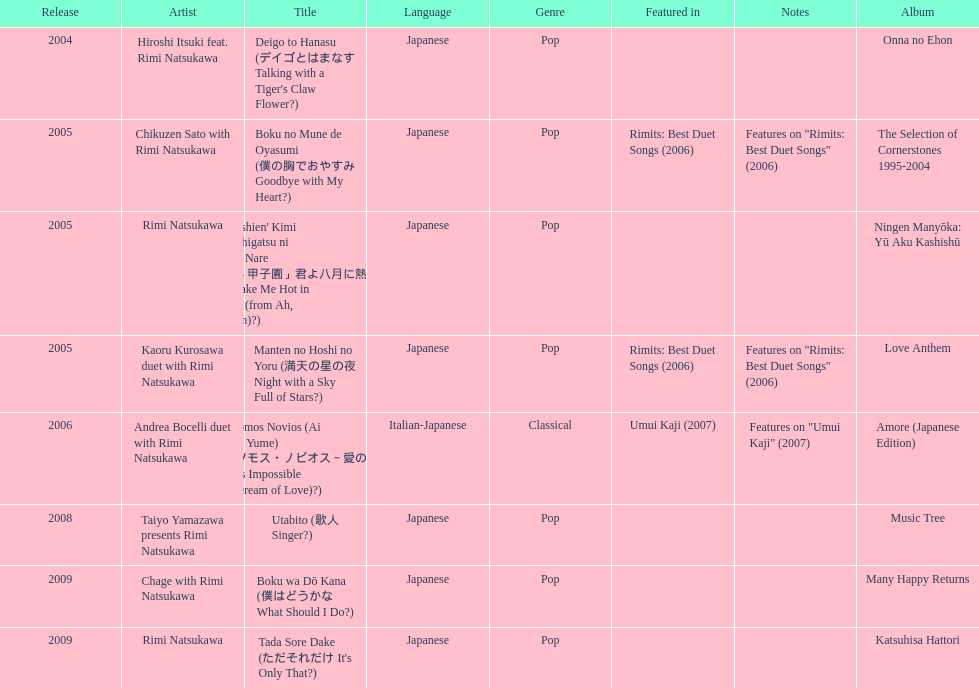What was the album released immediately before the one that had boku wa do kana on it? Music Tree. Could you parse the entire table? {'header': ['Release', 'Artist', 'Title', 'Language', 'Genre', 'Featured in', 'Notes', 'Album'], 'rows': [['2004', 'Hiroshi Itsuki feat. Rimi Natsukawa', "Deigo to Hanasu (デイゴとはまなす Talking with a Tiger's Claw Flower?)", 'Japanese', 'Pop', '', '', 'Onna no Ehon'], ['2005', 'Chikuzen Sato with Rimi Natsukawa', 'Boku no Mune de Oyasumi (僕の胸でおやすみ Goodbye with My Heart?)', 'Japanese', 'Pop', 'Rimits: Best Duet Songs (2006)', 'Features on "Rimits: Best Duet Songs" (2006)', 'The Selection of Cornerstones 1995-2004'], ['2005', 'Rimi Natsukawa', "'Aa Kōshien' Kimi yo Hachigatsu ni Atsuku Nare (「あゝ甲子園」君よ八月に熱くなれ You Make Me Hot in August (from Ah, Kōshien)?)", 'Japanese', 'Pop', '', '', 'Ningen Manyōka: Yū Aku Kashishū'], ['2005', 'Kaoru Kurosawa duet with Rimi Natsukawa', 'Manten no Hoshi no Yoru (満天の星の夜 Night with a Sky Full of Stars?)', 'Japanese', 'Pop', 'Rimits: Best Duet Songs (2006)', 'Features on "Rimits: Best Duet Songs" (2006)', 'Love Anthem'], ['2006', 'Andrea Bocelli duet with Rimi Natsukawa', "Somos Novios (Ai no Yume) (ソモス・ノビオス～愛の夢 It's Impossible (Dream of Love)?)", 'Italian-Japanese', 'Classical', 'Umui Kaji (2007)', 'Features on "Umui Kaji" (2007)', 'Amore (Japanese Edition)'], ['2008', 'Taiyo Yamazawa presents Rimi Natsukawa', 'Utabito (歌人 Singer?)', 'Japanese', 'Pop', '', '', 'Music Tree'], ['2009', 'Chage with Rimi Natsukawa', 'Boku wa Dō Kana (僕はどうかな What Should I Do?)', 'Japanese', 'Pop', '', '', 'Many Happy Returns'], ['2009', 'Rimi Natsukawa', "Tada Sore Dake (ただそれだけ It's Only That?)", 'Japanese', 'Pop', '', '', 'Katsuhisa Hattori']]} 